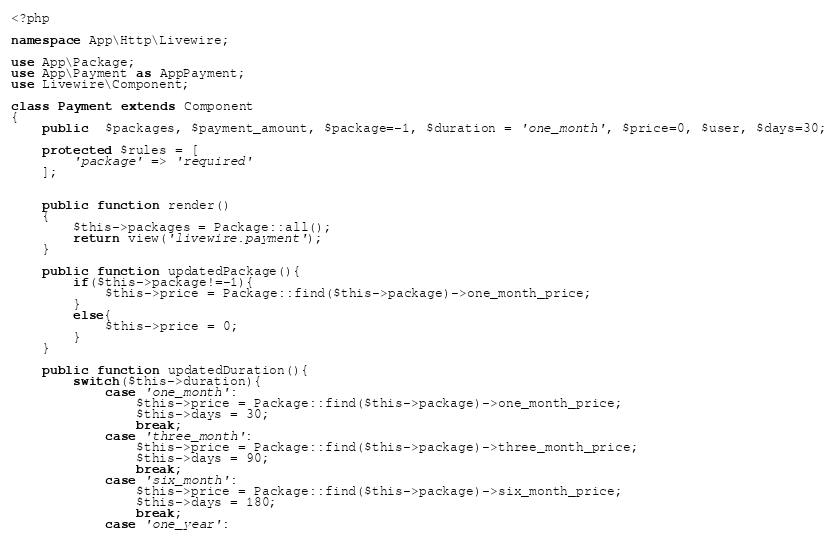<code> <loc_0><loc_0><loc_500><loc_500><_PHP_><?php

namespace App\Http\Livewire;

use App\Package;
use App\Payment as AppPayment;
use Livewire\Component;

class Payment extends Component
{
    public  $packages, $payment_amount, $package=-1, $duration = 'one_month', $price=0, $user, $days=30;

    protected $rules = [
        'package' => 'required'
    ];


    public function render()
    {
        $this->packages = Package::all();
        return view('livewire.payment');
    }

    public function updatedPackage(){
        if($this->package!=-1){
            $this->price = Package::find($this->package)->one_month_price;
        }
        else{
            $this->price = 0;
        }
    }

    public function updatedDuration(){
        switch($this->duration){
            case 'one_month':
                $this->price = Package::find($this->package)->one_month_price;
                $this->days = 30;
                break;
            case 'three_month':
                $this->price = Package::find($this->package)->three_month_price;
                $this->days = 90;
                break;
            case 'six_month':
                $this->price = Package::find($this->package)->six_month_price;
                $this->days = 180;
                break;
            case 'one_year':</code> 